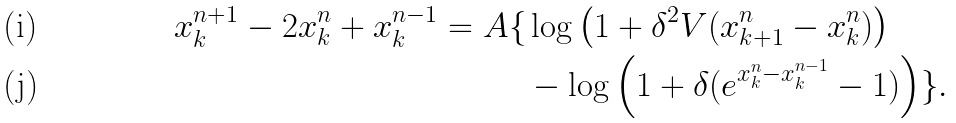<formula> <loc_0><loc_0><loc_500><loc_500>x _ { k } ^ { n + 1 } - 2 x _ { k } ^ { n } + x _ { k } ^ { n - 1 } = A \{ & \log \left ( 1 + \delta ^ { 2 } V ( x _ { k + 1 } ^ { n } - x _ { k } ^ { n } ) \right ) \\ & - \log \left ( 1 + \delta ( e ^ { x _ { k } ^ { n } - x _ { k } ^ { n - 1 } } - 1 ) \right ) \} .</formula> 